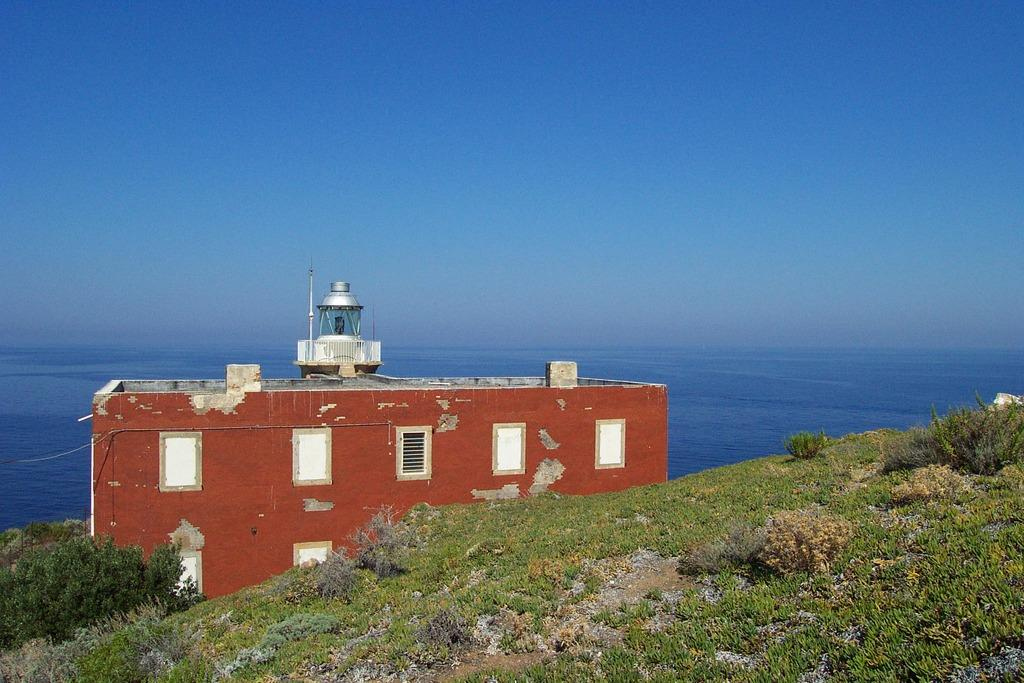What is the main subject in the center of the image? There is a building in the center of the image. What type of terrain is visible at the bottom of the image? There is grass at the bottom of the image. What can be seen in the distance in the background of the image? There is water visible in the background of the image. What color is the sofa in the image? There is no sofa present in the image. On which channel can you watch the events happening in the image? The image is a still photograph and cannot be watched on a channel. 